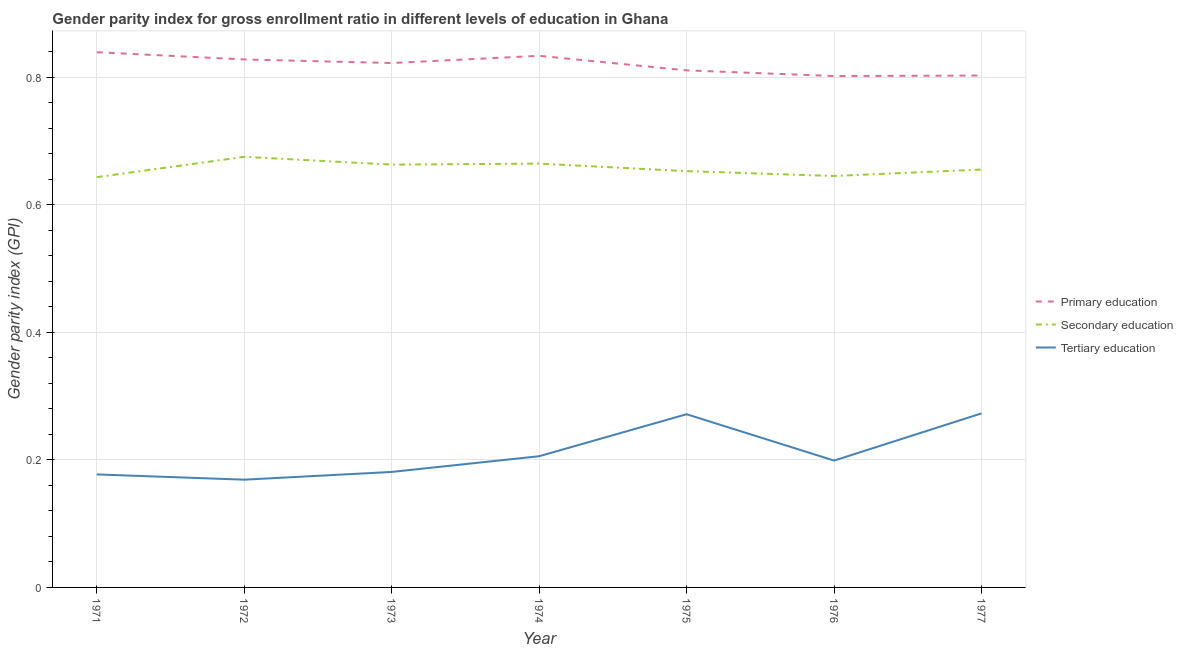How many different coloured lines are there?
Offer a very short reply. 3. What is the gender parity index in primary education in 1972?
Provide a succinct answer. 0.83. Across all years, what is the maximum gender parity index in secondary education?
Keep it short and to the point. 0.68. Across all years, what is the minimum gender parity index in primary education?
Your response must be concise. 0.8. In which year was the gender parity index in secondary education maximum?
Your response must be concise. 1972. In which year was the gender parity index in secondary education minimum?
Your response must be concise. 1971. What is the total gender parity index in primary education in the graph?
Offer a very short reply. 5.74. What is the difference between the gender parity index in secondary education in 1973 and that in 1975?
Make the answer very short. 0.01. What is the difference between the gender parity index in primary education in 1977 and the gender parity index in tertiary education in 1974?
Make the answer very short. 0.6. What is the average gender parity index in secondary education per year?
Your response must be concise. 0.66. In the year 1973, what is the difference between the gender parity index in primary education and gender parity index in tertiary education?
Provide a succinct answer. 0.64. What is the ratio of the gender parity index in secondary education in 1972 to that in 1973?
Give a very brief answer. 1.02. Is the gender parity index in primary education in 1972 less than that in 1975?
Offer a very short reply. No. Is the difference between the gender parity index in tertiary education in 1972 and 1976 greater than the difference between the gender parity index in secondary education in 1972 and 1976?
Provide a short and direct response. No. What is the difference between the highest and the second highest gender parity index in secondary education?
Your response must be concise. 0.01. What is the difference between the highest and the lowest gender parity index in tertiary education?
Ensure brevity in your answer.  0.1. In how many years, is the gender parity index in primary education greater than the average gender parity index in primary education taken over all years?
Keep it short and to the point. 4. Does the gender parity index in tertiary education monotonically increase over the years?
Give a very brief answer. No. Is the gender parity index in primary education strictly greater than the gender parity index in secondary education over the years?
Provide a short and direct response. Yes. How many lines are there?
Your response must be concise. 3. How many years are there in the graph?
Your answer should be very brief. 7. What is the difference between two consecutive major ticks on the Y-axis?
Your response must be concise. 0.2. Does the graph contain grids?
Give a very brief answer. Yes. Where does the legend appear in the graph?
Your response must be concise. Center right. How are the legend labels stacked?
Provide a short and direct response. Vertical. What is the title of the graph?
Offer a terse response. Gender parity index for gross enrollment ratio in different levels of education in Ghana. Does "Social Protection and Labor" appear as one of the legend labels in the graph?
Your response must be concise. No. What is the label or title of the X-axis?
Your answer should be compact. Year. What is the label or title of the Y-axis?
Ensure brevity in your answer.  Gender parity index (GPI). What is the Gender parity index (GPI) of Primary education in 1971?
Provide a short and direct response. 0.84. What is the Gender parity index (GPI) in Secondary education in 1971?
Offer a terse response. 0.64. What is the Gender parity index (GPI) in Tertiary education in 1971?
Your response must be concise. 0.18. What is the Gender parity index (GPI) in Primary education in 1972?
Ensure brevity in your answer.  0.83. What is the Gender parity index (GPI) of Secondary education in 1972?
Ensure brevity in your answer.  0.68. What is the Gender parity index (GPI) in Tertiary education in 1972?
Provide a succinct answer. 0.17. What is the Gender parity index (GPI) of Primary education in 1973?
Give a very brief answer. 0.82. What is the Gender parity index (GPI) of Secondary education in 1973?
Provide a succinct answer. 0.66. What is the Gender parity index (GPI) in Tertiary education in 1973?
Your answer should be very brief. 0.18. What is the Gender parity index (GPI) in Primary education in 1974?
Make the answer very short. 0.83. What is the Gender parity index (GPI) of Secondary education in 1974?
Provide a succinct answer. 0.66. What is the Gender parity index (GPI) of Tertiary education in 1974?
Your answer should be very brief. 0.21. What is the Gender parity index (GPI) in Primary education in 1975?
Provide a succinct answer. 0.81. What is the Gender parity index (GPI) of Secondary education in 1975?
Give a very brief answer. 0.65. What is the Gender parity index (GPI) in Tertiary education in 1975?
Ensure brevity in your answer.  0.27. What is the Gender parity index (GPI) of Primary education in 1976?
Your response must be concise. 0.8. What is the Gender parity index (GPI) in Secondary education in 1976?
Offer a very short reply. 0.65. What is the Gender parity index (GPI) of Tertiary education in 1976?
Keep it short and to the point. 0.2. What is the Gender parity index (GPI) in Primary education in 1977?
Make the answer very short. 0.8. What is the Gender parity index (GPI) in Secondary education in 1977?
Your response must be concise. 0.66. What is the Gender parity index (GPI) of Tertiary education in 1977?
Provide a short and direct response. 0.27. Across all years, what is the maximum Gender parity index (GPI) of Primary education?
Provide a succinct answer. 0.84. Across all years, what is the maximum Gender parity index (GPI) of Secondary education?
Keep it short and to the point. 0.68. Across all years, what is the maximum Gender parity index (GPI) in Tertiary education?
Your answer should be compact. 0.27. Across all years, what is the minimum Gender parity index (GPI) in Primary education?
Give a very brief answer. 0.8. Across all years, what is the minimum Gender parity index (GPI) in Secondary education?
Give a very brief answer. 0.64. Across all years, what is the minimum Gender parity index (GPI) of Tertiary education?
Your answer should be compact. 0.17. What is the total Gender parity index (GPI) in Primary education in the graph?
Keep it short and to the point. 5.74. What is the total Gender parity index (GPI) in Secondary education in the graph?
Provide a succinct answer. 4.6. What is the total Gender parity index (GPI) in Tertiary education in the graph?
Provide a short and direct response. 1.48. What is the difference between the Gender parity index (GPI) in Primary education in 1971 and that in 1972?
Your answer should be very brief. 0.01. What is the difference between the Gender parity index (GPI) in Secondary education in 1971 and that in 1972?
Your answer should be compact. -0.03. What is the difference between the Gender parity index (GPI) in Tertiary education in 1971 and that in 1972?
Provide a short and direct response. 0.01. What is the difference between the Gender parity index (GPI) of Primary education in 1971 and that in 1973?
Provide a succinct answer. 0.02. What is the difference between the Gender parity index (GPI) of Secondary education in 1971 and that in 1973?
Your answer should be very brief. -0.02. What is the difference between the Gender parity index (GPI) of Tertiary education in 1971 and that in 1973?
Offer a very short reply. -0. What is the difference between the Gender parity index (GPI) in Primary education in 1971 and that in 1974?
Ensure brevity in your answer.  0.01. What is the difference between the Gender parity index (GPI) of Secondary education in 1971 and that in 1974?
Provide a short and direct response. -0.02. What is the difference between the Gender parity index (GPI) in Tertiary education in 1971 and that in 1974?
Ensure brevity in your answer.  -0.03. What is the difference between the Gender parity index (GPI) of Primary education in 1971 and that in 1975?
Offer a terse response. 0.03. What is the difference between the Gender parity index (GPI) of Secondary education in 1971 and that in 1975?
Make the answer very short. -0.01. What is the difference between the Gender parity index (GPI) in Tertiary education in 1971 and that in 1975?
Keep it short and to the point. -0.09. What is the difference between the Gender parity index (GPI) in Primary education in 1971 and that in 1976?
Provide a succinct answer. 0.04. What is the difference between the Gender parity index (GPI) in Secondary education in 1971 and that in 1976?
Make the answer very short. -0. What is the difference between the Gender parity index (GPI) in Tertiary education in 1971 and that in 1976?
Give a very brief answer. -0.02. What is the difference between the Gender parity index (GPI) of Primary education in 1971 and that in 1977?
Your response must be concise. 0.04. What is the difference between the Gender parity index (GPI) of Secondary education in 1971 and that in 1977?
Offer a very short reply. -0.01. What is the difference between the Gender parity index (GPI) of Tertiary education in 1971 and that in 1977?
Your response must be concise. -0.1. What is the difference between the Gender parity index (GPI) of Primary education in 1972 and that in 1973?
Your answer should be very brief. 0.01. What is the difference between the Gender parity index (GPI) in Secondary education in 1972 and that in 1973?
Your answer should be very brief. 0.01. What is the difference between the Gender parity index (GPI) in Tertiary education in 1972 and that in 1973?
Your answer should be compact. -0.01. What is the difference between the Gender parity index (GPI) of Primary education in 1972 and that in 1974?
Keep it short and to the point. -0.01. What is the difference between the Gender parity index (GPI) in Secondary education in 1972 and that in 1974?
Make the answer very short. 0.01. What is the difference between the Gender parity index (GPI) of Tertiary education in 1972 and that in 1974?
Your answer should be compact. -0.04. What is the difference between the Gender parity index (GPI) in Primary education in 1972 and that in 1975?
Provide a succinct answer. 0.02. What is the difference between the Gender parity index (GPI) of Secondary education in 1972 and that in 1975?
Provide a succinct answer. 0.02. What is the difference between the Gender parity index (GPI) in Tertiary education in 1972 and that in 1975?
Your response must be concise. -0.1. What is the difference between the Gender parity index (GPI) in Primary education in 1972 and that in 1976?
Provide a short and direct response. 0.03. What is the difference between the Gender parity index (GPI) in Secondary education in 1972 and that in 1976?
Offer a very short reply. 0.03. What is the difference between the Gender parity index (GPI) in Tertiary education in 1972 and that in 1976?
Keep it short and to the point. -0.03. What is the difference between the Gender parity index (GPI) in Primary education in 1972 and that in 1977?
Your answer should be compact. 0.03. What is the difference between the Gender parity index (GPI) of Secondary education in 1972 and that in 1977?
Ensure brevity in your answer.  0.02. What is the difference between the Gender parity index (GPI) in Tertiary education in 1972 and that in 1977?
Your answer should be compact. -0.1. What is the difference between the Gender parity index (GPI) in Primary education in 1973 and that in 1974?
Your answer should be very brief. -0.01. What is the difference between the Gender parity index (GPI) of Secondary education in 1973 and that in 1974?
Your response must be concise. -0. What is the difference between the Gender parity index (GPI) of Tertiary education in 1973 and that in 1974?
Make the answer very short. -0.02. What is the difference between the Gender parity index (GPI) of Primary education in 1973 and that in 1975?
Ensure brevity in your answer.  0.01. What is the difference between the Gender parity index (GPI) in Secondary education in 1973 and that in 1975?
Provide a succinct answer. 0.01. What is the difference between the Gender parity index (GPI) of Tertiary education in 1973 and that in 1975?
Make the answer very short. -0.09. What is the difference between the Gender parity index (GPI) in Primary education in 1973 and that in 1976?
Your response must be concise. 0.02. What is the difference between the Gender parity index (GPI) of Secondary education in 1973 and that in 1976?
Keep it short and to the point. 0.02. What is the difference between the Gender parity index (GPI) of Tertiary education in 1973 and that in 1976?
Keep it short and to the point. -0.02. What is the difference between the Gender parity index (GPI) in Primary education in 1973 and that in 1977?
Your answer should be very brief. 0.02. What is the difference between the Gender parity index (GPI) in Secondary education in 1973 and that in 1977?
Make the answer very short. 0.01. What is the difference between the Gender parity index (GPI) in Tertiary education in 1973 and that in 1977?
Provide a short and direct response. -0.09. What is the difference between the Gender parity index (GPI) in Primary education in 1974 and that in 1975?
Your response must be concise. 0.02. What is the difference between the Gender parity index (GPI) in Secondary education in 1974 and that in 1975?
Provide a succinct answer. 0.01. What is the difference between the Gender parity index (GPI) in Tertiary education in 1974 and that in 1975?
Your answer should be compact. -0.07. What is the difference between the Gender parity index (GPI) of Primary education in 1974 and that in 1976?
Make the answer very short. 0.03. What is the difference between the Gender parity index (GPI) in Secondary education in 1974 and that in 1976?
Provide a short and direct response. 0.02. What is the difference between the Gender parity index (GPI) of Tertiary education in 1974 and that in 1976?
Ensure brevity in your answer.  0.01. What is the difference between the Gender parity index (GPI) in Primary education in 1974 and that in 1977?
Keep it short and to the point. 0.03. What is the difference between the Gender parity index (GPI) of Secondary education in 1974 and that in 1977?
Your answer should be compact. 0.01. What is the difference between the Gender parity index (GPI) of Tertiary education in 1974 and that in 1977?
Provide a short and direct response. -0.07. What is the difference between the Gender parity index (GPI) in Primary education in 1975 and that in 1976?
Ensure brevity in your answer.  0.01. What is the difference between the Gender parity index (GPI) in Secondary education in 1975 and that in 1976?
Offer a terse response. 0.01. What is the difference between the Gender parity index (GPI) in Tertiary education in 1975 and that in 1976?
Provide a short and direct response. 0.07. What is the difference between the Gender parity index (GPI) of Primary education in 1975 and that in 1977?
Offer a very short reply. 0.01. What is the difference between the Gender parity index (GPI) of Secondary education in 1975 and that in 1977?
Provide a short and direct response. -0. What is the difference between the Gender parity index (GPI) in Tertiary education in 1975 and that in 1977?
Ensure brevity in your answer.  -0. What is the difference between the Gender parity index (GPI) of Primary education in 1976 and that in 1977?
Your response must be concise. -0. What is the difference between the Gender parity index (GPI) of Secondary education in 1976 and that in 1977?
Provide a succinct answer. -0.01. What is the difference between the Gender parity index (GPI) of Tertiary education in 1976 and that in 1977?
Your answer should be very brief. -0.07. What is the difference between the Gender parity index (GPI) in Primary education in 1971 and the Gender parity index (GPI) in Secondary education in 1972?
Provide a succinct answer. 0.16. What is the difference between the Gender parity index (GPI) of Primary education in 1971 and the Gender parity index (GPI) of Tertiary education in 1972?
Ensure brevity in your answer.  0.67. What is the difference between the Gender parity index (GPI) in Secondary education in 1971 and the Gender parity index (GPI) in Tertiary education in 1972?
Ensure brevity in your answer.  0.47. What is the difference between the Gender parity index (GPI) in Primary education in 1971 and the Gender parity index (GPI) in Secondary education in 1973?
Offer a terse response. 0.18. What is the difference between the Gender parity index (GPI) of Primary education in 1971 and the Gender parity index (GPI) of Tertiary education in 1973?
Give a very brief answer. 0.66. What is the difference between the Gender parity index (GPI) in Secondary education in 1971 and the Gender parity index (GPI) in Tertiary education in 1973?
Provide a succinct answer. 0.46. What is the difference between the Gender parity index (GPI) of Primary education in 1971 and the Gender parity index (GPI) of Secondary education in 1974?
Your answer should be compact. 0.17. What is the difference between the Gender parity index (GPI) of Primary education in 1971 and the Gender parity index (GPI) of Tertiary education in 1974?
Make the answer very short. 0.63. What is the difference between the Gender parity index (GPI) of Secondary education in 1971 and the Gender parity index (GPI) of Tertiary education in 1974?
Give a very brief answer. 0.44. What is the difference between the Gender parity index (GPI) of Primary education in 1971 and the Gender parity index (GPI) of Secondary education in 1975?
Provide a succinct answer. 0.19. What is the difference between the Gender parity index (GPI) of Primary education in 1971 and the Gender parity index (GPI) of Tertiary education in 1975?
Offer a very short reply. 0.57. What is the difference between the Gender parity index (GPI) in Secondary education in 1971 and the Gender parity index (GPI) in Tertiary education in 1975?
Offer a very short reply. 0.37. What is the difference between the Gender parity index (GPI) of Primary education in 1971 and the Gender parity index (GPI) of Secondary education in 1976?
Make the answer very short. 0.19. What is the difference between the Gender parity index (GPI) of Primary education in 1971 and the Gender parity index (GPI) of Tertiary education in 1976?
Keep it short and to the point. 0.64. What is the difference between the Gender parity index (GPI) of Secondary education in 1971 and the Gender parity index (GPI) of Tertiary education in 1976?
Ensure brevity in your answer.  0.44. What is the difference between the Gender parity index (GPI) in Primary education in 1971 and the Gender parity index (GPI) in Secondary education in 1977?
Offer a very short reply. 0.18. What is the difference between the Gender parity index (GPI) in Primary education in 1971 and the Gender parity index (GPI) in Tertiary education in 1977?
Your response must be concise. 0.57. What is the difference between the Gender parity index (GPI) in Secondary education in 1971 and the Gender parity index (GPI) in Tertiary education in 1977?
Provide a succinct answer. 0.37. What is the difference between the Gender parity index (GPI) of Primary education in 1972 and the Gender parity index (GPI) of Secondary education in 1973?
Offer a terse response. 0.17. What is the difference between the Gender parity index (GPI) in Primary education in 1972 and the Gender parity index (GPI) in Tertiary education in 1973?
Provide a succinct answer. 0.65. What is the difference between the Gender parity index (GPI) in Secondary education in 1972 and the Gender parity index (GPI) in Tertiary education in 1973?
Ensure brevity in your answer.  0.49. What is the difference between the Gender parity index (GPI) of Primary education in 1972 and the Gender parity index (GPI) of Secondary education in 1974?
Provide a short and direct response. 0.16. What is the difference between the Gender parity index (GPI) of Primary education in 1972 and the Gender parity index (GPI) of Tertiary education in 1974?
Your answer should be compact. 0.62. What is the difference between the Gender parity index (GPI) in Secondary education in 1972 and the Gender parity index (GPI) in Tertiary education in 1974?
Give a very brief answer. 0.47. What is the difference between the Gender parity index (GPI) in Primary education in 1972 and the Gender parity index (GPI) in Secondary education in 1975?
Give a very brief answer. 0.18. What is the difference between the Gender parity index (GPI) of Primary education in 1972 and the Gender parity index (GPI) of Tertiary education in 1975?
Your answer should be very brief. 0.56. What is the difference between the Gender parity index (GPI) of Secondary education in 1972 and the Gender parity index (GPI) of Tertiary education in 1975?
Offer a very short reply. 0.4. What is the difference between the Gender parity index (GPI) in Primary education in 1972 and the Gender parity index (GPI) in Secondary education in 1976?
Provide a succinct answer. 0.18. What is the difference between the Gender parity index (GPI) in Primary education in 1972 and the Gender parity index (GPI) in Tertiary education in 1976?
Keep it short and to the point. 0.63. What is the difference between the Gender parity index (GPI) in Secondary education in 1972 and the Gender parity index (GPI) in Tertiary education in 1976?
Offer a very short reply. 0.48. What is the difference between the Gender parity index (GPI) in Primary education in 1972 and the Gender parity index (GPI) in Secondary education in 1977?
Offer a terse response. 0.17. What is the difference between the Gender parity index (GPI) of Primary education in 1972 and the Gender parity index (GPI) of Tertiary education in 1977?
Ensure brevity in your answer.  0.56. What is the difference between the Gender parity index (GPI) of Secondary education in 1972 and the Gender parity index (GPI) of Tertiary education in 1977?
Offer a very short reply. 0.4. What is the difference between the Gender parity index (GPI) in Primary education in 1973 and the Gender parity index (GPI) in Secondary education in 1974?
Your response must be concise. 0.16. What is the difference between the Gender parity index (GPI) of Primary education in 1973 and the Gender parity index (GPI) of Tertiary education in 1974?
Ensure brevity in your answer.  0.62. What is the difference between the Gender parity index (GPI) in Secondary education in 1973 and the Gender parity index (GPI) in Tertiary education in 1974?
Offer a very short reply. 0.46. What is the difference between the Gender parity index (GPI) in Primary education in 1973 and the Gender parity index (GPI) in Secondary education in 1975?
Your answer should be very brief. 0.17. What is the difference between the Gender parity index (GPI) of Primary education in 1973 and the Gender parity index (GPI) of Tertiary education in 1975?
Ensure brevity in your answer.  0.55. What is the difference between the Gender parity index (GPI) in Secondary education in 1973 and the Gender parity index (GPI) in Tertiary education in 1975?
Offer a very short reply. 0.39. What is the difference between the Gender parity index (GPI) of Primary education in 1973 and the Gender parity index (GPI) of Secondary education in 1976?
Provide a succinct answer. 0.18. What is the difference between the Gender parity index (GPI) in Primary education in 1973 and the Gender parity index (GPI) in Tertiary education in 1976?
Your answer should be very brief. 0.62. What is the difference between the Gender parity index (GPI) of Secondary education in 1973 and the Gender parity index (GPI) of Tertiary education in 1976?
Keep it short and to the point. 0.46. What is the difference between the Gender parity index (GPI) of Primary education in 1973 and the Gender parity index (GPI) of Secondary education in 1977?
Ensure brevity in your answer.  0.17. What is the difference between the Gender parity index (GPI) in Primary education in 1973 and the Gender parity index (GPI) in Tertiary education in 1977?
Give a very brief answer. 0.55. What is the difference between the Gender parity index (GPI) of Secondary education in 1973 and the Gender parity index (GPI) of Tertiary education in 1977?
Your answer should be very brief. 0.39. What is the difference between the Gender parity index (GPI) in Primary education in 1974 and the Gender parity index (GPI) in Secondary education in 1975?
Your answer should be very brief. 0.18. What is the difference between the Gender parity index (GPI) of Primary education in 1974 and the Gender parity index (GPI) of Tertiary education in 1975?
Your answer should be very brief. 0.56. What is the difference between the Gender parity index (GPI) in Secondary education in 1974 and the Gender parity index (GPI) in Tertiary education in 1975?
Your answer should be very brief. 0.39. What is the difference between the Gender parity index (GPI) in Primary education in 1974 and the Gender parity index (GPI) in Secondary education in 1976?
Ensure brevity in your answer.  0.19. What is the difference between the Gender parity index (GPI) of Primary education in 1974 and the Gender parity index (GPI) of Tertiary education in 1976?
Provide a short and direct response. 0.63. What is the difference between the Gender parity index (GPI) of Secondary education in 1974 and the Gender parity index (GPI) of Tertiary education in 1976?
Offer a very short reply. 0.47. What is the difference between the Gender parity index (GPI) of Primary education in 1974 and the Gender parity index (GPI) of Secondary education in 1977?
Your answer should be very brief. 0.18. What is the difference between the Gender parity index (GPI) in Primary education in 1974 and the Gender parity index (GPI) in Tertiary education in 1977?
Your answer should be compact. 0.56. What is the difference between the Gender parity index (GPI) of Secondary education in 1974 and the Gender parity index (GPI) of Tertiary education in 1977?
Your answer should be very brief. 0.39. What is the difference between the Gender parity index (GPI) in Primary education in 1975 and the Gender parity index (GPI) in Secondary education in 1976?
Your answer should be very brief. 0.17. What is the difference between the Gender parity index (GPI) in Primary education in 1975 and the Gender parity index (GPI) in Tertiary education in 1976?
Offer a terse response. 0.61. What is the difference between the Gender parity index (GPI) in Secondary education in 1975 and the Gender parity index (GPI) in Tertiary education in 1976?
Provide a succinct answer. 0.45. What is the difference between the Gender parity index (GPI) in Primary education in 1975 and the Gender parity index (GPI) in Secondary education in 1977?
Your answer should be very brief. 0.16. What is the difference between the Gender parity index (GPI) in Primary education in 1975 and the Gender parity index (GPI) in Tertiary education in 1977?
Provide a succinct answer. 0.54. What is the difference between the Gender parity index (GPI) in Secondary education in 1975 and the Gender parity index (GPI) in Tertiary education in 1977?
Offer a very short reply. 0.38. What is the difference between the Gender parity index (GPI) of Primary education in 1976 and the Gender parity index (GPI) of Secondary education in 1977?
Offer a terse response. 0.15. What is the difference between the Gender parity index (GPI) of Primary education in 1976 and the Gender parity index (GPI) of Tertiary education in 1977?
Keep it short and to the point. 0.53. What is the difference between the Gender parity index (GPI) in Secondary education in 1976 and the Gender parity index (GPI) in Tertiary education in 1977?
Provide a short and direct response. 0.37. What is the average Gender parity index (GPI) in Primary education per year?
Keep it short and to the point. 0.82. What is the average Gender parity index (GPI) of Secondary education per year?
Ensure brevity in your answer.  0.66. What is the average Gender parity index (GPI) in Tertiary education per year?
Make the answer very short. 0.21. In the year 1971, what is the difference between the Gender parity index (GPI) in Primary education and Gender parity index (GPI) in Secondary education?
Provide a short and direct response. 0.2. In the year 1971, what is the difference between the Gender parity index (GPI) of Primary education and Gender parity index (GPI) of Tertiary education?
Give a very brief answer. 0.66. In the year 1971, what is the difference between the Gender parity index (GPI) in Secondary education and Gender parity index (GPI) in Tertiary education?
Keep it short and to the point. 0.47. In the year 1972, what is the difference between the Gender parity index (GPI) of Primary education and Gender parity index (GPI) of Secondary education?
Your response must be concise. 0.15. In the year 1972, what is the difference between the Gender parity index (GPI) of Primary education and Gender parity index (GPI) of Tertiary education?
Offer a very short reply. 0.66. In the year 1972, what is the difference between the Gender parity index (GPI) in Secondary education and Gender parity index (GPI) in Tertiary education?
Give a very brief answer. 0.51. In the year 1973, what is the difference between the Gender parity index (GPI) in Primary education and Gender parity index (GPI) in Secondary education?
Offer a terse response. 0.16. In the year 1973, what is the difference between the Gender parity index (GPI) of Primary education and Gender parity index (GPI) of Tertiary education?
Give a very brief answer. 0.64. In the year 1973, what is the difference between the Gender parity index (GPI) in Secondary education and Gender parity index (GPI) in Tertiary education?
Give a very brief answer. 0.48. In the year 1974, what is the difference between the Gender parity index (GPI) in Primary education and Gender parity index (GPI) in Secondary education?
Offer a terse response. 0.17. In the year 1974, what is the difference between the Gender parity index (GPI) in Primary education and Gender parity index (GPI) in Tertiary education?
Keep it short and to the point. 0.63. In the year 1974, what is the difference between the Gender parity index (GPI) of Secondary education and Gender parity index (GPI) of Tertiary education?
Offer a terse response. 0.46. In the year 1975, what is the difference between the Gender parity index (GPI) of Primary education and Gender parity index (GPI) of Secondary education?
Make the answer very short. 0.16. In the year 1975, what is the difference between the Gender parity index (GPI) in Primary education and Gender parity index (GPI) in Tertiary education?
Give a very brief answer. 0.54. In the year 1975, what is the difference between the Gender parity index (GPI) of Secondary education and Gender parity index (GPI) of Tertiary education?
Offer a terse response. 0.38. In the year 1976, what is the difference between the Gender parity index (GPI) in Primary education and Gender parity index (GPI) in Secondary education?
Keep it short and to the point. 0.16. In the year 1976, what is the difference between the Gender parity index (GPI) of Primary education and Gender parity index (GPI) of Tertiary education?
Your answer should be very brief. 0.6. In the year 1976, what is the difference between the Gender parity index (GPI) in Secondary education and Gender parity index (GPI) in Tertiary education?
Your answer should be compact. 0.45. In the year 1977, what is the difference between the Gender parity index (GPI) in Primary education and Gender parity index (GPI) in Secondary education?
Provide a short and direct response. 0.15. In the year 1977, what is the difference between the Gender parity index (GPI) of Primary education and Gender parity index (GPI) of Tertiary education?
Give a very brief answer. 0.53. In the year 1977, what is the difference between the Gender parity index (GPI) of Secondary education and Gender parity index (GPI) of Tertiary education?
Your answer should be compact. 0.38. What is the ratio of the Gender parity index (GPI) in Primary education in 1971 to that in 1972?
Your answer should be compact. 1.01. What is the ratio of the Gender parity index (GPI) of Secondary education in 1971 to that in 1972?
Provide a succinct answer. 0.95. What is the ratio of the Gender parity index (GPI) in Tertiary education in 1971 to that in 1972?
Your response must be concise. 1.05. What is the ratio of the Gender parity index (GPI) of Primary education in 1971 to that in 1973?
Offer a very short reply. 1.02. What is the ratio of the Gender parity index (GPI) of Secondary education in 1971 to that in 1973?
Make the answer very short. 0.97. What is the ratio of the Gender parity index (GPI) in Tertiary education in 1971 to that in 1973?
Ensure brevity in your answer.  0.98. What is the ratio of the Gender parity index (GPI) of Primary education in 1971 to that in 1974?
Ensure brevity in your answer.  1.01. What is the ratio of the Gender parity index (GPI) of Tertiary education in 1971 to that in 1974?
Ensure brevity in your answer.  0.86. What is the ratio of the Gender parity index (GPI) of Primary education in 1971 to that in 1975?
Offer a very short reply. 1.04. What is the ratio of the Gender parity index (GPI) in Secondary education in 1971 to that in 1975?
Your response must be concise. 0.99. What is the ratio of the Gender parity index (GPI) in Tertiary education in 1971 to that in 1975?
Provide a short and direct response. 0.65. What is the ratio of the Gender parity index (GPI) in Primary education in 1971 to that in 1976?
Ensure brevity in your answer.  1.05. What is the ratio of the Gender parity index (GPI) of Tertiary education in 1971 to that in 1976?
Your answer should be compact. 0.89. What is the ratio of the Gender parity index (GPI) of Primary education in 1971 to that in 1977?
Offer a terse response. 1.05. What is the ratio of the Gender parity index (GPI) of Secondary education in 1971 to that in 1977?
Give a very brief answer. 0.98. What is the ratio of the Gender parity index (GPI) of Tertiary education in 1971 to that in 1977?
Keep it short and to the point. 0.65. What is the ratio of the Gender parity index (GPI) of Primary education in 1972 to that in 1973?
Make the answer very short. 1.01. What is the ratio of the Gender parity index (GPI) in Secondary education in 1972 to that in 1973?
Ensure brevity in your answer.  1.02. What is the ratio of the Gender parity index (GPI) in Tertiary education in 1972 to that in 1973?
Your response must be concise. 0.93. What is the ratio of the Gender parity index (GPI) in Secondary education in 1972 to that in 1974?
Offer a very short reply. 1.02. What is the ratio of the Gender parity index (GPI) of Tertiary education in 1972 to that in 1974?
Keep it short and to the point. 0.82. What is the ratio of the Gender parity index (GPI) in Primary education in 1972 to that in 1975?
Your response must be concise. 1.02. What is the ratio of the Gender parity index (GPI) in Secondary education in 1972 to that in 1975?
Offer a very short reply. 1.03. What is the ratio of the Gender parity index (GPI) of Tertiary education in 1972 to that in 1975?
Your response must be concise. 0.62. What is the ratio of the Gender parity index (GPI) in Primary education in 1972 to that in 1976?
Your response must be concise. 1.03. What is the ratio of the Gender parity index (GPI) in Secondary education in 1972 to that in 1976?
Your response must be concise. 1.05. What is the ratio of the Gender parity index (GPI) of Tertiary education in 1972 to that in 1976?
Ensure brevity in your answer.  0.85. What is the ratio of the Gender parity index (GPI) of Primary education in 1972 to that in 1977?
Your response must be concise. 1.03. What is the ratio of the Gender parity index (GPI) of Secondary education in 1972 to that in 1977?
Your answer should be compact. 1.03. What is the ratio of the Gender parity index (GPI) in Tertiary education in 1972 to that in 1977?
Make the answer very short. 0.62. What is the ratio of the Gender parity index (GPI) in Primary education in 1973 to that in 1974?
Your response must be concise. 0.99. What is the ratio of the Gender parity index (GPI) in Secondary education in 1973 to that in 1974?
Provide a succinct answer. 1. What is the ratio of the Gender parity index (GPI) of Tertiary education in 1973 to that in 1974?
Ensure brevity in your answer.  0.88. What is the ratio of the Gender parity index (GPI) of Primary education in 1973 to that in 1975?
Your response must be concise. 1.01. What is the ratio of the Gender parity index (GPI) in Secondary education in 1973 to that in 1975?
Offer a very short reply. 1.02. What is the ratio of the Gender parity index (GPI) in Tertiary education in 1973 to that in 1975?
Provide a succinct answer. 0.67. What is the ratio of the Gender parity index (GPI) of Primary education in 1973 to that in 1976?
Keep it short and to the point. 1.03. What is the ratio of the Gender parity index (GPI) in Secondary education in 1973 to that in 1976?
Provide a short and direct response. 1.03. What is the ratio of the Gender parity index (GPI) in Tertiary education in 1973 to that in 1976?
Provide a succinct answer. 0.91. What is the ratio of the Gender parity index (GPI) in Primary education in 1973 to that in 1977?
Offer a very short reply. 1.02. What is the ratio of the Gender parity index (GPI) in Secondary education in 1973 to that in 1977?
Your response must be concise. 1.01. What is the ratio of the Gender parity index (GPI) in Tertiary education in 1973 to that in 1977?
Your answer should be compact. 0.66. What is the ratio of the Gender parity index (GPI) in Primary education in 1974 to that in 1975?
Offer a terse response. 1.03. What is the ratio of the Gender parity index (GPI) in Secondary education in 1974 to that in 1975?
Give a very brief answer. 1.02. What is the ratio of the Gender parity index (GPI) in Tertiary education in 1974 to that in 1975?
Provide a short and direct response. 0.76. What is the ratio of the Gender parity index (GPI) in Primary education in 1974 to that in 1976?
Keep it short and to the point. 1.04. What is the ratio of the Gender parity index (GPI) of Secondary education in 1974 to that in 1976?
Provide a short and direct response. 1.03. What is the ratio of the Gender parity index (GPI) of Tertiary education in 1974 to that in 1976?
Make the answer very short. 1.03. What is the ratio of the Gender parity index (GPI) in Secondary education in 1974 to that in 1977?
Your answer should be compact. 1.01. What is the ratio of the Gender parity index (GPI) in Tertiary education in 1974 to that in 1977?
Keep it short and to the point. 0.75. What is the ratio of the Gender parity index (GPI) of Primary education in 1975 to that in 1976?
Ensure brevity in your answer.  1.01. What is the ratio of the Gender parity index (GPI) in Secondary education in 1975 to that in 1976?
Your answer should be very brief. 1.01. What is the ratio of the Gender parity index (GPI) in Tertiary education in 1975 to that in 1976?
Provide a succinct answer. 1.37. What is the ratio of the Gender parity index (GPI) in Primary education in 1975 to that in 1977?
Offer a very short reply. 1.01. What is the ratio of the Gender parity index (GPI) in Tertiary education in 1975 to that in 1977?
Your answer should be very brief. 1. What is the ratio of the Gender parity index (GPI) of Secondary education in 1976 to that in 1977?
Offer a terse response. 0.98. What is the ratio of the Gender parity index (GPI) in Tertiary education in 1976 to that in 1977?
Keep it short and to the point. 0.73. What is the difference between the highest and the second highest Gender parity index (GPI) in Primary education?
Provide a short and direct response. 0.01. What is the difference between the highest and the second highest Gender parity index (GPI) of Secondary education?
Provide a succinct answer. 0.01. What is the difference between the highest and the second highest Gender parity index (GPI) of Tertiary education?
Ensure brevity in your answer.  0. What is the difference between the highest and the lowest Gender parity index (GPI) in Primary education?
Your answer should be compact. 0.04. What is the difference between the highest and the lowest Gender parity index (GPI) of Secondary education?
Ensure brevity in your answer.  0.03. What is the difference between the highest and the lowest Gender parity index (GPI) of Tertiary education?
Your answer should be very brief. 0.1. 